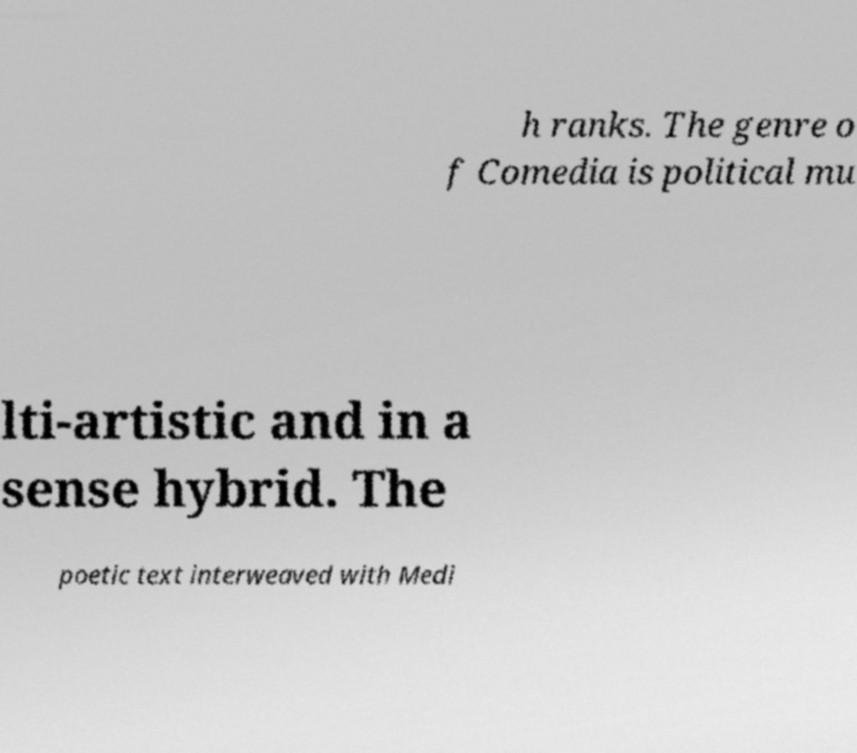Could you assist in decoding the text presented in this image and type it out clearly? h ranks. The genre o f Comedia is political mu lti-artistic and in a sense hybrid. The poetic text interweaved with Medi 